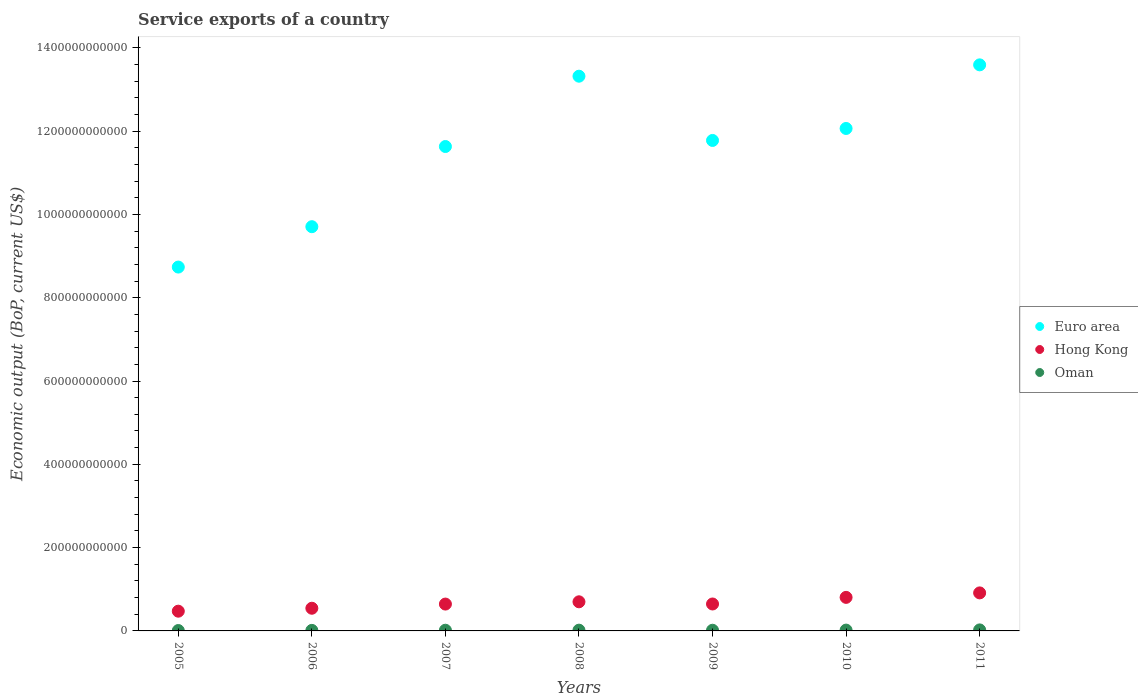How many different coloured dotlines are there?
Provide a short and direct response. 3. Is the number of dotlines equal to the number of legend labels?
Offer a very short reply. Yes. What is the service exports in Hong Kong in 2005?
Ensure brevity in your answer.  4.74e+1. Across all years, what is the maximum service exports in Hong Kong?
Provide a succinct answer. 9.13e+1. Across all years, what is the minimum service exports in Euro area?
Give a very brief answer. 8.74e+11. What is the total service exports in Hong Kong in the graph?
Give a very brief answer. 4.73e+11. What is the difference between the service exports in Oman in 2007 and that in 2010?
Ensure brevity in your answer.  -2.76e+08. What is the difference between the service exports in Hong Kong in 2009 and the service exports in Euro area in 2010?
Your response must be concise. -1.14e+12. What is the average service exports in Euro area per year?
Provide a short and direct response. 1.15e+12. In the year 2006, what is the difference between the service exports in Euro area and service exports in Hong Kong?
Provide a short and direct response. 9.16e+11. What is the ratio of the service exports in Oman in 2005 to that in 2010?
Offer a terse response. 0.48. Is the difference between the service exports in Euro area in 2005 and 2006 greater than the difference between the service exports in Hong Kong in 2005 and 2006?
Make the answer very short. No. What is the difference between the highest and the second highest service exports in Euro area?
Your answer should be compact. 2.72e+1. What is the difference between the highest and the lowest service exports in Oman?
Your answer should be very brief. 1.50e+09. Is it the case that in every year, the sum of the service exports in Hong Kong and service exports in Euro area  is greater than the service exports in Oman?
Offer a very short reply. Yes. Is the service exports in Hong Kong strictly greater than the service exports in Euro area over the years?
Keep it short and to the point. No. How many years are there in the graph?
Your response must be concise. 7. What is the difference between two consecutive major ticks on the Y-axis?
Make the answer very short. 2.00e+11. Does the graph contain any zero values?
Ensure brevity in your answer.  No. Does the graph contain grids?
Keep it short and to the point. No. Where does the legend appear in the graph?
Keep it short and to the point. Center right. How are the legend labels stacked?
Provide a succinct answer. Vertical. What is the title of the graph?
Offer a terse response. Service exports of a country. Does "Oman" appear as one of the legend labels in the graph?
Offer a very short reply. Yes. What is the label or title of the X-axis?
Offer a terse response. Years. What is the label or title of the Y-axis?
Make the answer very short. Economic output (BoP, current US$). What is the Economic output (BoP, current US$) of Euro area in 2005?
Your answer should be compact. 8.74e+11. What is the Economic output (BoP, current US$) of Hong Kong in 2005?
Your answer should be compact. 4.74e+1. What is the Economic output (BoP, current US$) in Oman in 2005?
Offer a terse response. 9.39e+08. What is the Economic output (BoP, current US$) of Euro area in 2006?
Offer a terse response. 9.70e+11. What is the Economic output (BoP, current US$) of Hong Kong in 2006?
Your answer should be very brief. 5.44e+1. What is the Economic output (BoP, current US$) in Oman in 2006?
Provide a succinct answer. 1.31e+09. What is the Economic output (BoP, current US$) in Euro area in 2007?
Offer a terse response. 1.16e+12. What is the Economic output (BoP, current US$) in Hong Kong in 2007?
Make the answer very short. 6.45e+1. What is the Economic output (BoP, current US$) in Oman in 2007?
Provide a succinct answer. 1.68e+09. What is the Economic output (BoP, current US$) of Euro area in 2008?
Offer a very short reply. 1.33e+12. What is the Economic output (BoP, current US$) in Hong Kong in 2008?
Offer a very short reply. 6.99e+1. What is the Economic output (BoP, current US$) of Oman in 2008?
Provide a short and direct response. 1.83e+09. What is the Economic output (BoP, current US$) in Euro area in 2009?
Make the answer very short. 1.18e+12. What is the Economic output (BoP, current US$) of Hong Kong in 2009?
Make the answer very short. 6.47e+1. What is the Economic output (BoP, current US$) in Oman in 2009?
Your answer should be compact. 1.62e+09. What is the Economic output (BoP, current US$) of Euro area in 2010?
Give a very brief answer. 1.21e+12. What is the Economic output (BoP, current US$) of Hong Kong in 2010?
Provide a short and direct response. 8.05e+1. What is the Economic output (BoP, current US$) in Oman in 2010?
Offer a terse response. 1.96e+09. What is the Economic output (BoP, current US$) in Euro area in 2011?
Your answer should be very brief. 1.36e+12. What is the Economic output (BoP, current US$) of Hong Kong in 2011?
Keep it short and to the point. 9.13e+1. What is the Economic output (BoP, current US$) of Oman in 2011?
Make the answer very short. 2.44e+09. Across all years, what is the maximum Economic output (BoP, current US$) of Euro area?
Your answer should be compact. 1.36e+12. Across all years, what is the maximum Economic output (BoP, current US$) of Hong Kong?
Provide a succinct answer. 9.13e+1. Across all years, what is the maximum Economic output (BoP, current US$) in Oman?
Provide a short and direct response. 2.44e+09. Across all years, what is the minimum Economic output (BoP, current US$) in Euro area?
Your answer should be compact. 8.74e+11. Across all years, what is the minimum Economic output (BoP, current US$) of Hong Kong?
Your answer should be compact. 4.74e+1. Across all years, what is the minimum Economic output (BoP, current US$) in Oman?
Make the answer very short. 9.39e+08. What is the total Economic output (BoP, current US$) of Euro area in the graph?
Give a very brief answer. 8.08e+12. What is the total Economic output (BoP, current US$) in Hong Kong in the graph?
Your answer should be very brief. 4.73e+11. What is the total Economic output (BoP, current US$) in Oman in the graph?
Provide a short and direct response. 1.18e+1. What is the difference between the Economic output (BoP, current US$) of Euro area in 2005 and that in 2006?
Offer a very short reply. -9.69e+1. What is the difference between the Economic output (BoP, current US$) of Hong Kong in 2005 and that in 2006?
Your response must be concise. -7.06e+09. What is the difference between the Economic output (BoP, current US$) of Oman in 2005 and that in 2006?
Ensure brevity in your answer.  -3.72e+08. What is the difference between the Economic output (BoP, current US$) of Euro area in 2005 and that in 2007?
Provide a short and direct response. -2.89e+11. What is the difference between the Economic output (BoP, current US$) of Hong Kong in 2005 and that in 2007?
Keep it short and to the point. -1.71e+1. What is the difference between the Economic output (BoP, current US$) in Oman in 2005 and that in 2007?
Make the answer very short. -7.44e+08. What is the difference between the Economic output (BoP, current US$) in Euro area in 2005 and that in 2008?
Your response must be concise. -4.58e+11. What is the difference between the Economic output (BoP, current US$) in Hong Kong in 2005 and that in 2008?
Keep it short and to the point. -2.25e+1. What is the difference between the Economic output (BoP, current US$) of Oman in 2005 and that in 2008?
Give a very brief answer. -8.87e+08. What is the difference between the Economic output (BoP, current US$) in Euro area in 2005 and that in 2009?
Give a very brief answer. -3.04e+11. What is the difference between the Economic output (BoP, current US$) in Hong Kong in 2005 and that in 2009?
Your answer should be very brief. -1.73e+1. What is the difference between the Economic output (BoP, current US$) in Oman in 2005 and that in 2009?
Your answer should be compact. -6.81e+08. What is the difference between the Economic output (BoP, current US$) in Euro area in 2005 and that in 2010?
Provide a succinct answer. -3.33e+11. What is the difference between the Economic output (BoP, current US$) in Hong Kong in 2005 and that in 2010?
Your response must be concise. -3.32e+1. What is the difference between the Economic output (BoP, current US$) in Oman in 2005 and that in 2010?
Make the answer very short. -1.02e+09. What is the difference between the Economic output (BoP, current US$) in Euro area in 2005 and that in 2011?
Provide a short and direct response. -4.85e+11. What is the difference between the Economic output (BoP, current US$) in Hong Kong in 2005 and that in 2011?
Give a very brief answer. -4.39e+1. What is the difference between the Economic output (BoP, current US$) of Oman in 2005 and that in 2011?
Provide a short and direct response. -1.50e+09. What is the difference between the Economic output (BoP, current US$) of Euro area in 2006 and that in 2007?
Your answer should be very brief. -1.92e+11. What is the difference between the Economic output (BoP, current US$) of Hong Kong in 2006 and that in 2007?
Offer a terse response. -1.00e+1. What is the difference between the Economic output (BoP, current US$) in Oman in 2006 and that in 2007?
Make the answer very short. -3.72e+08. What is the difference between the Economic output (BoP, current US$) of Euro area in 2006 and that in 2008?
Your response must be concise. -3.61e+11. What is the difference between the Economic output (BoP, current US$) in Hong Kong in 2006 and that in 2008?
Offer a terse response. -1.55e+1. What is the difference between the Economic output (BoP, current US$) in Oman in 2006 and that in 2008?
Your answer should be compact. -5.15e+08. What is the difference between the Economic output (BoP, current US$) of Euro area in 2006 and that in 2009?
Keep it short and to the point. -2.07e+11. What is the difference between the Economic output (BoP, current US$) of Hong Kong in 2006 and that in 2009?
Your answer should be very brief. -1.02e+1. What is the difference between the Economic output (BoP, current US$) of Oman in 2006 and that in 2009?
Make the answer very short. -3.09e+08. What is the difference between the Economic output (BoP, current US$) of Euro area in 2006 and that in 2010?
Offer a very short reply. -2.36e+11. What is the difference between the Economic output (BoP, current US$) in Hong Kong in 2006 and that in 2010?
Provide a short and direct response. -2.61e+1. What is the difference between the Economic output (BoP, current US$) in Oman in 2006 and that in 2010?
Ensure brevity in your answer.  -6.48e+08. What is the difference between the Economic output (BoP, current US$) of Euro area in 2006 and that in 2011?
Make the answer very short. -3.89e+11. What is the difference between the Economic output (BoP, current US$) in Hong Kong in 2006 and that in 2011?
Offer a very short reply. -3.69e+1. What is the difference between the Economic output (BoP, current US$) in Oman in 2006 and that in 2011?
Keep it short and to the point. -1.13e+09. What is the difference between the Economic output (BoP, current US$) in Euro area in 2007 and that in 2008?
Make the answer very short. -1.69e+11. What is the difference between the Economic output (BoP, current US$) of Hong Kong in 2007 and that in 2008?
Keep it short and to the point. -5.45e+09. What is the difference between the Economic output (BoP, current US$) of Oman in 2007 and that in 2008?
Give a very brief answer. -1.43e+08. What is the difference between the Economic output (BoP, current US$) of Euro area in 2007 and that in 2009?
Make the answer very short. -1.46e+1. What is the difference between the Economic output (BoP, current US$) of Hong Kong in 2007 and that in 2009?
Offer a very short reply. -2.16e+08. What is the difference between the Economic output (BoP, current US$) of Oman in 2007 and that in 2009?
Make the answer very short. 6.24e+07. What is the difference between the Economic output (BoP, current US$) of Euro area in 2007 and that in 2010?
Make the answer very short. -4.33e+1. What is the difference between the Economic output (BoP, current US$) of Hong Kong in 2007 and that in 2010?
Ensure brevity in your answer.  -1.61e+1. What is the difference between the Economic output (BoP, current US$) of Oman in 2007 and that in 2010?
Keep it short and to the point. -2.76e+08. What is the difference between the Economic output (BoP, current US$) of Euro area in 2007 and that in 2011?
Provide a succinct answer. -1.96e+11. What is the difference between the Economic output (BoP, current US$) in Hong Kong in 2007 and that in 2011?
Give a very brief answer. -2.68e+1. What is the difference between the Economic output (BoP, current US$) in Oman in 2007 and that in 2011?
Your answer should be very brief. -7.59e+08. What is the difference between the Economic output (BoP, current US$) of Euro area in 2008 and that in 2009?
Ensure brevity in your answer.  1.54e+11. What is the difference between the Economic output (BoP, current US$) in Hong Kong in 2008 and that in 2009?
Provide a short and direct response. 5.24e+09. What is the difference between the Economic output (BoP, current US$) of Oman in 2008 and that in 2009?
Provide a succinct answer. 2.05e+08. What is the difference between the Economic output (BoP, current US$) in Euro area in 2008 and that in 2010?
Your response must be concise. 1.25e+11. What is the difference between the Economic output (BoP, current US$) of Hong Kong in 2008 and that in 2010?
Give a very brief answer. -1.06e+1. What is the difference between the Economic output (BoP, current US$) in Oman in 2008 and that in 2010?
Provide a short and direct response. -1.33e+08. What is the difference between the Economic output (BoP, current US$) of Euro area in 2008 and that in 2011?
Your answer should be very brief. -2.72e+1. What is the difference between the Economic output (BoP, current US$) in Hong Kong in 2008 and that in 2011?
Provide a short and direct response. -2.14e+1. What is the difference between the Economic output (BoP, current US$) in Oman in 2008 and that in 2011?
Give a very brief answer. -6.16e+08. What is the difference between the Economic output (BoP, current US$) of Euro area in 2009 and that in 2010?
Make the answer very short. -2.88e+1. What is the difference between the Economic output (BoP, current US$) in Hong Kong in 2009 and that in 2010?
Give a very brief answer. -1.59e+1. What is the difference between the Economic output (BoP, current US$) in Oman in 2009 and that in 2010?
Ensure brevity in your answer.  -3.38e+08. What is the difference between the Economic output (BoP, current US$) in Euro area in 2009 and that in 2011?
Make the answer very short. -1.81e+11. What is the difference between the Economic output (BoP, current US$) in Hong Kong in 2009 and that in 2011?
Ensure brevity in your answer.  -2.66e+1. What is the difference between the Economic output (BoP, current US$) in Oman in 2009 and that in 2011?
Your response must be concise. -8.22e+08. What is the difference between the Economic output (BoP, current US$) of Euro area in 2010 and that in 2011?
Offer a very short reply. -1.53e+11. What is the difference between the Economic output (BoP, current US$) in Hong Kong in 2010 and that in 2011?
Your answer should be compact. -1.08e+1. What is the difference between the Economic output (BoP, current US$) in Oman in 2010 and that in 2011?
Make the answer very short. -4.84e+08. What is the difference between the Economic output (BoP, current US$) in Euro area in 2005 and the Economic output (BoP, current US$) in Hong Kong in 2006?
Give a very brief answer. 8.19e+11. What is the difference between the Economic output (BoP, current US$) in Euro area in 2005 and the Economic output (BoP, current US$) in Oman in 2006?
Provide a short and direct response. 8.72e+11. What is the difference between the Economic output (BoP, current US$) in Hong Kong in 2005 and the Economic output (BoP, current US$) in Oman in 2006?
Offer a very short reply. 4.61e+1. What is the difference between the Economic output (BoP, current US$) of Euro area in 2005 and the Economic output (BoP, current US$) of Hong Kong in 2007?
Provide a succinct answer. 8.09e+11. What is the difference between the Economic output (BoP, current US$) in Euro area in 2005 and the Economic output (BoP, current US$) in Oman in 2007?
Ensure brevity in your answer.  8.72e+11. What is the difference between the Economic output (BoP, current US$) in Hong Kong in 2005 and the Economic output (BoP, current US$) in Oman in 2007?
Your response must be concise. 4.57e+1. What is the difference between the Economic output (BoP, current US$) in Euro area in 2005 and the Economic output (BoP, current US$) in Hong Kong in 2008?
Your answer should be very brief. 8.04e+11. What is the difference between the Economic output (BoP, current US$) in Euro area in 2005 and the Economic output (BoP, current US$) in Oman in 2008?
Provide a succinct answer. 8.72e+11. What is the difference between the Economic output (BoP, current US$) of Hong Kong in 2005 and the Economic output (BoP, current US$) of Oman in 2008?
Provide a short and direct response. 4.56e+1. What is the difference between the Economic output (BoP, current US$) in Euro area in 2005 and the Economic output (BoP, current US$) in Hong Kong in 2009?
Provide a short and direct response. 8.09e+11. What is the difference between the Economic output (BoP, current US$) in Euro area in 2005 and the Economic output (BoP, current US$) in Oman in 2009?
Provide a short and direct response. 8.72e+11. What is the difference between the Economic output (BoP, current US$) in Hong Kong in 2005 and the Economic output (BoP, current US$) in Oman in 2009?
Offer a very short reply. 4.58e+1. What is the difference between the Economic output (BoP, current US$) of Euro area in 2005 and the Economic output (BoP, current US$) of Hong Kong in 2010?
Offer a terse response. 7.93e+11. What is the difference between the Economic output (BoP, current US$) of Euro area in 2005 and the Economic output (BoP, current US$) of Oman in 2010?
Provide a short and direct response. 8.72e+11. What is the difference between the Economic output (BoP, current US$) of Hong Kong in 2005 and the Economic output (BoP, current US$) of Oman in 2010?
Keep it short and to the point. 4.54e+1. What is the difference between the Economic output (BoP, current US$) of Euro area in 2005 and the Economic output (BoP, current US$) of Hong Kong in 2011?
Keep it short and to the point. 7.82e+11. What is the difference between the Economic output (BoP, current US$) of Euro area in 2005 and the Economic output (BoP, current US$) of Oman in 2011?
Your answer should be very brief. 8.71e+11. What is the difference between the Economic output (BoP, current US$) of Hong Kong in 2005 and the Economic output (BoP, current US$) of Oman in 2011?
Offer a terse response. 4.49e+1. What is the difference between the Economic output (BoP, current US$) in Euro area in 2006 and the Economic output (BoP, current US$) in Hong Kong in 2007?
Offer a very short reply. 9.06e+11. What is the difference between the Economic output (BoP, current US$) of Euro area in 2006 and the Economic output (BoP, current US$) of Oman in 2007?
Your response must be concise. 9.69e+11. What is the difference between the Economic output (BoP, current US$) in Hong Kong in 2006 and the Economic output (BoP, current US$) in Oman in 2007?
Keep it short and to the point. 5.28e+1. What is the difference between the Economic output (BoP, current US$) of Euro area in 2006 and the Economic output (BoP, current US$) of Hong Kong in 2008?
Your response must be concise. 9.01e+11. What is the difference between the Economic output (BoP, current US$) of Euro area in 2006 and the Economic output (BoP, current US$) of Oman in 2008?
Your answer should be compact. 9.69e+11. What is the difference between the Economic output (BoP, current US$) in Hong Kong in 2006 and the Economic output (BoP, current US$) in Oman in 2008?
Keep it short and to the point. 5.26e+1. What is the difference between the Economic output (BoP, current US$) of Euro area in 2006 and the Economic output (BoP, current US$) of Hong Kong in 2009?
Your answer should be very brief. 9.06e+11. What is the difference between the Economic output (BoP, current US$) of Euro area in 2006 and the Economic output (BoP, current US$) of Oman in 2009?
Offer a terse response. 9.69e+11. What is the difference between the Economic output (BoP, current US$) of Hong Kong in 2006 and the Economic output (BoP, current US$) of Oman in 2009?
Offer a very short reply. 5.28e+1. What is the difference between the Economic output (BoP, current US$) of Euro area in 2006 and the Economic output (BoP, current US$) of Hong Kong in 2010?
Offer a terse response. 8.90e+11. What is the difference between the Economic output (BoP, current US$) in Euro area in 2006 and the Economic output (BoP, current US$) in Oman in 2010?
Your response must be concise. 9.69e+11. What is the difference between the Economic output (BoP, current US$) in Hong Kong in 2006 and the Economic output (BoP, current US$) in Oman in 2010?
Provide a succinct answer. 5.25e+1. What is the difference between the Economic output (BoP, current US$) in Euro area in 2006 and the Economic output (BoP, current US$) in Hong Kong in 2011?
Provide a short and direct response. 8.79e+11. What is the difference between the Economic output (BoP, current US$) of Euro area in 2006 and the Economic output (BoP, current US$) of Oman in 2011?
Make the answer very short. 9.68e+11. What is the difference between the Economic output (BoP, current US$) in Hong Kong in 2006 and the Economic output (BoP, current US$) in Oman in 2011?
Provide a succinct answer. 5.20e+1. What is the difference between the Economic output (BoP, current US$) of Euro area in 2007 and the Economic output (BoP, current US$) of Hong Kong in 2008?
Your answer should be very brief. 1.09e+12. What is the difference between the Economic output (BoP, current US$) of Euro area in 2007 and the Economic output (BoP, current US$) of Oman in 2008?
Offer a terse response. 1.16e+12. What is the difference between the Economic output (BoP, current US$) of Hong Kong in 2007 and the Economic output (BoP, current US$) of Oman in 2008?
Your answer should be compact. 6.26e+1. What is the difference between the Economic output (BoP, current US$) in Euro area in 2007 and the Economic output (BoP, current US$) in Hong Kong in 2009?
Offer a very short reply. 1.10e+12. What is the difference between the Economic output (BoP, current US$) of Euro area in 2007 and the Economic output (BoP, current US$) of Oman in 2009?
Your answer should be compact. 1.16e+12. What is the difference between the Economic output (BoP, current US$) in Hong Kong in 2007 and the Economic output (BoP, current US$) in Oman in 2009?
Give a very brief answer. 6.28e+1. What is the difference between the Economic output (BoP, current US$) in Euro area in 2007 and the Economic output (BoP, current US$) in Hong Kong in 2010?
Your answer should be compact. 1.08e+12. What is the difference between the Economic output (BoP, current US$) in Euro area in 2007 and the Economic output (BoP, current US$) in Oman in 2010?
Offer a terse response. 1.16e+12. What is the difference between the Economic output (BoP, current US$) in Hong Kong in 2007 and the Economic output (BoP, current US$) in Oman in 2010?
Your response must be concise. 6.25e+1. What is the difference between the Economic output (BoP, current US$) in Euro area in 2007 and the Economic output (BoP, current US$) in Hong Kong in 2011?
Offer a very short reply. 1.07e+12. What is the difference between the Economic output (BoP, current US$) in Euro area in 2007 and the Economic output (BoP, current US$) in Oman in 2011?
Offer a terse response. 1.16e+12. What is the difference between the Economic output (BoP, current US$) in Hong Kong in 2007 and the Economic output (BoP, current US$) in Oman in 2011?
Make the answer very short. 6.20e+1. What is the difference between the Economic output (BoP, current US$) of Euro area in 2008 and the Economic output (BoP, current US$) of Hong Kong in 2009?
Give a very brief answer. 1.27e+12. What is the difference between the Economic output (BoP, current US$) in Euro area in 2008 and the Economic output (BoP, current US$) in Oman in 2009?
Your response must be concise. 1.33e+12. What is the difference between the Economic output (BoP, current US$) in Hong Kong in 2008 and the Economic output (BoP, current US$) in Oman in 2009?
Offer a very short reply. 6.83e+1. What is the difference between the Economic output (BoP, current US$) in Euro area in 2008 and the Economic output (BoP, current US$) in Hong Kong in 2010?
Make the answer very short. 1.25e+12. What is the difference between the Economic output (BoP, current US$) in Euro area in 2008 and the Economic output (BoP, current US$) in Oman in 2010?
Offer a terse response. 1.33e+12. What is the difference between the Economic output (BoP, current US$) in Hong Kong in 2008 and the Economic output (BoP, current US$) in Oman in 2010?
Make the answer very short. 6.79e+1. What is the difference between the Economic output (BoP, current US$) in Euro area in 2008 and the Economic output (BoP, current US$) in Hong Kong in 2011?
Make the answer very short. 1.24e+12. What is the difference between the Economic output (BoP, current US$) in Euro area in 2008 and the Economic output (BoP, current US$) in Oman in 2011?
Ensure brevity in your answer.  1.33e+12. What is the difference between the Economic output (BoP, current US$) of Hong Kong in 2008 and the Economic output (BoP, current US$) of Oman in 2011?
Offer a terse response. 6.75e+1. What is the difference between the Economic output (BoP, current US$) in Euro area in 2009 and the Economic output (BoP, current US$) in Hong Kong in 2010?
Make the answer very short. 1.10e+12. What is the difference between the Economic output (BoP, current US$) in Euro area in 2009 and the Economic output (BoP, current US$) in Oman in 2010?
Your response must be concise. 1.18e+12. What is the difference between the Economic output (BoP, current US$) in Hong Kong in 2009 and the Economic output (BoP, current US$) in Oman in 2010?
Provide a short and direct response. 6.27e+1. What is the difference between the Economic output (BoP, current US$) in Euro area in 2009 and the Economic output (BoP, current US$) in Hong Kong in 2011?
Make the answer very short. 1.09e+12. What is the difference between the Economic output (BoP, current US$) of Euro area in 2009 and the Economic output (BoP, current US$) of Oman in 2011?
Your answer should be compact. 1.18e+12. What is the difference between the Economic output (BoP, current US$) of Hong Kong in 2009 and the Economic output (BoP, current US$) of Oman in 2011?
Offer a terse response. 6.22e+1. What is the difference between the Economic output (BoP, current US$) in Euro area in 2010 and the Economic output (BoP, current US$) in Hong Kong in 2011?
Your response must be concise. 1.12e+12. What is the difference between the Economic output (BoP, current US$) of Euro area in 2010 and the Economic output (BoP, current US$) of Oman in 2011?
Provide a short and direct response. 1.20e+12. What is the difference between the Economic output (BoP, current US$) in Hong Kong in 2010 and the Economic output (BoP, current US$) in Oman in 2011?
Give a very brief answer. 7.81e+1. What is the average Economic output (BoP, current US$) in Euro area per year?
Ensure brevity in your answer.  1.15e+12. What is the average Economic output (BoP, current US$) of Hong Kong per year?
Your response must be concise. 6.75e+1. What is the average Economic output (BoP, current US$) in Oman per year?
Provide a short and direct response. 1.68e+09. In the year 2005, what is the difference between the Economic output (BoP, current US$) of Euro area and Economic output (BoP, current US$) of Hong Kong?
Provide a succinct answer. 8.26e+11. In the year 2005, what is the difference between the Economic output (BoP, current US$) of Euro area and Economic output (BoP, current US$) of Oman?
Your response must be concise. 8.73e+11. In the year 2005, what is the difference between the Economic output (BoP, current US$) in Hong Kong and Economic output (BoP, current US$) in Oman?
Make the answer very short. 4.64e+1. In the year 2006, what is the difference between the Economic output (BoP, current US$) of Euro area and Economic output (BoP, current US$) of Hong Kong?
Ensure brevity in your answer.  9.16e+11. In the year 2006, what is the difference between the Economic output (BoP, current US$) of Euro area and Economic output (BoP, current US$) of Oman?
Offer a terse response. 9.69e+11. In the year 2006, what is the difference between the Economic output (BoP, current US$) in Hong Kong and Economic output (BoP, current US$) in Oman?
Provide a succinct answer. 5.31e+1. In the year 2007, what is the difference between the Economic output (BoP, current US$) in Euro area and Economic output (BoP, current US$) in Hong Kong?
Give a very brief answer. 1.10e+12. In the year 2007, what is the difference between the Economic output (BoP, current US$) in Euro area and Economic output (BoP, current US$) in Oman?
Make the answer very short. 1.16e+12. In the year 2007, what is the difference between the Economic output (BoP, current US$) in Hong Kong and Economic output (BoP, current US$) in Oman?
Your answer should be very brief. 6.28e+1. In the year 2008, what is the difference between the Economic output (BoP, current US$) of Euro area and Economic output (BoP, current US$) of Hong Kong?
Your answer should be compact. 1.26e+12. In the year 2008, what is the difference between the Economic output (BoP, current US$) in Euro area and Economic output (BoP, current US$) in Oman?
Provide a succinct answer. 1.33e+12. In the year 2008, what is the difference between the Economic output (BoP, current US$) in Hong Kong and Economic output (BoP, current US$) in Oman?
Ensure brevity in your answer.  6.81e+1. In the year 2009, what is the difference between the Economic output (BoP, current US$) of Euro area and Economic output (BoP, current US$) of Hong Kong?
Provide a succinct answer. 1.11e+12. In the year 2009, what is the difference between the Economic output (BoP, current US$) in Euro area and Economic output (BoP, current US$) in Oman?
Your answer should be very brief. 1.18e+12. In the year 2009, what is the difference between the Economic output (BoP, current US$) of Hong Kong and Economic output (BoP, current US$) of Oman?
Ensure brevity in your answer.  6.30e+1. In the year 2010, what is the difference between the Economic output (BoP, current US$) of Euro area and Economic output (BoP, current US$) of Hong Kong?
Provide a succinct answer. 1.13e+12. In the year 2010, what is the difference between the Economic output (BoP, current US$) in Euro area and Economic output (BoP, current US$) in Oman?
Your answer should be compact. 1.20e+12. In the year 2010, what is the difference between the Economic output (BoP, current US$) of Hong Kong and Economic output (BoP, current US$) of Oman?
Ensure brevity in your answer.  7.86e+1. In the year 2011, what is the difference between the Economic output (BoP, current US$) in Euro area and Economic output (BoP, current US$) in Hong Kong?
Give a very brief answer. 1.27e+12. In the year 2011, what is the difference between the Economic output (BoP, current US$) of Euro area and Economic output (BoP, current US$) of Oman?
Your answer should be very brief. 1.36e+12. In the year 2011, what is the difference between the Economic output (BoP, current US$) of Hong Kong and Economic output (BoP, current US$) of Oman?
Ensure brevity in your answer.  8.89e+1. What is the ratio of the Economic output (BoP, current US$) in Euro area in 2005 to that in 2006?
Provide a short and direct response. 0.9. What is the ratio of the Economic output (BoP, current US$) of Hong Kong in 2005 to that in 2006?
Offer a very short reply. 0.87. What is the ratio of the Economic output (BoP, current US$) in Oman in 2005 to that in 2006?
Ensure brevity in your answer.  0.72. What is the ratio of the Economic output (BoP, current US$) in Euro area in 2005 to that in 2007?
Your response must be concise. 0.75. What is the ratio of the Economic output (BoP, current US$) in Hong Kong in 2005 to that in 2007?
Your answer should be very brief. 0.74. What is the ratio of the Economic output (BoP, current US$) in Oman in 2005 to that in 2007?
Provide a succinct answer. 0.56. What is the ratio of the Economic output (BoP, current US$) in Euro area in 2005 to that in 2008?
Ensure brevity in your answer.  0.66. What is the ratio of the Economic output (BoP, current US$) in Hong Kong in 2005 to that in 2008?
Offer a terse response. 0.68. What is the ratio of the Economic output (BoP, current US$) of Oman in 2005 to that in 2008?
Your response must be concise. 0.51. What is the ratio of the Economic output (BoP, current US$) in Euro area in 2005 to that in 2009?
Ensure brevity in your answer.  0.74. What is the ratio of the Economic output (BoP, current US$) of Hong Kong in 2005 to that in 2009?
Your response must be concise. 0.73. What is the ratio of the Economic output (BoP, current US$) in Oman in 2005 to that in 2009?
Your answer should be very brief. 0.58. What is the ratio of the Economic output (BoP, current US$) in Euro area in 2005 to that in 2010?
Your answer should be very brief. 0.72. What is the ratio of the Economic output (BoP, current US$) of Hong Kong in 2005 to that in 2010?
Ensure brevity in your answer.  0.59. What is the ratio of the Economic output (BoP, current US$) of Oman in 2005 to that in 2010?
Offer a terse response. 0.48. What is the ratio of the Economic output (BoP, current US$) in Euro area in 2005 to that in 2011?
Your answer should be very brief. 0.64. What is the ratio of the Economic output (BoP, current US$) of Hong Kong in 2005 to that in 2011?
Your answer should be compact. 0.52. What is the ratio of the Economic output (BoP, current US$) of Oman in 2005 to that in 2011?
Make the answer very short. 0.38. What is the ratio of the Economic output (BoP, current US$) of Euro area in 2006 to that in 2007?
Offer a terse response. 0.83. What is the ratio of the Economic output (BoP, current US$) in Hong Kong in 2006 to that in 2007?
Your answer should be very brief. 0.84. What is the ratio of the Economic output (BoP, current US$) in Oman in 2006 to that in 2007?
Make the answer very short. 0.78. What is the ratio of the Economic output (BoP, current US$) of Euro area in 2006 to that in 2008?
Offer a very short reply. 0.73. What is the ratio of the Economic output (BoP, current US$) of Hong Kong in 2006 to that in 2008?
Provide a short and direct response. 0.78. What is the ratio of the Economic output (BoP, current US$) of Oman in 2006 to that in 2008?
Offer a very short reply. 0.72. What is the ratio of the Economic output (BoP, current US$) of Euro area in 2006 to that in 2009?
Provide a short and direct response. 0.82. What is the ratio of the Economic output (BoP, current US$) in Hong Kong in 2006 to that in 2009?
Give a very brief answer. 0.84. What is the ratio of the Economic output (BoP, current US$) in Oman in 2006 to that in 2009?
Your answer should be very brief. 0.81. What is the ratio of the Economic output (BoP, current US$) in Euro area in 2006 to that in 2010?
Provide a succinct answer. 0.8. What is the ratio of the Economic output (BoP, current US$) of Hong Kong in 2006 to that in 2010?
Provide a succinct answer. 0.68. What is the ratio of the Economic output (BoP, current US$) in Oman in 2006 to that in 2010?
Your answer should be very brief. 0.67. What is the ratio of the Economic output (BoP, current US$) of Euro area in 2006 to that in 2011?
Offer a very short reply. 0.71. What is the ratio of the Economic output (BoP, current US$) in Hong Kong in 2006 to that in 2011?
Make the answer very short. 0.6. What is the ratio of the Economic output (BoP, current US$) of Oman in 2006 to that in 2011?
Make the answer very short. 0.54. What is the ratio of the Economic output (BoP, current US$) of Euro area in 2007 to that in 2008?
Provide a succinct answer. 0.87. What is the ratio of the Economic output (BoP, current US$) in Hong Kong in 2007 to that in 2008?
Your answer should be compact. 0.92. What is the ratio of the Economic output (BoP, current US$) in Oman in 2007 to that in 2008?
Offer a terse response. 0.92. What is the ratio of the Economic output (BoP, current US$) in Euro area in 2007 to that in 2009?
Your answer should be very brief. 0.99. What is the ratio of the Economic output (BoP, current US$) of Hong Kong in 2007 to that in 2009?
Your answer should be compact. 1. What is the ratio of the Economic output (BoP, current US$) in Euro area in 2007 to that in 2010?
Your response must be concise. 0.96. What is the ratio of the Economic output (BoP, current US$) in Hong Kong in 2007 to that in 2010?
Your answer should be compact. 0.8. What is the ratio of the Economic output (BoP, current US$) in Oman in 2007 to that in 2010?
Make the answer very short. 0.86. What is the ratio of the Economic output (BoP, current US$) in Euro area in 2007 to that in 2011?
Your answer should be very brief. 0.86. What is the ratio of the Economic output (BoP, current US$) in Hong Kong in 2007 to that in 2011?
Your answer should be compact. 0.71. What is the ratio of the Economic output (BoP, current US$) of Oman in 2007 to that in 2011?
Offer a very short reply. 0.69. What is the ratio of the Economic output (BoP, current US$) of Euro area in 2008 to that in 2009?
Ensure brevity in your answer.  1.13. What is the ratio of the Economic output (BoP, current US$) in Hong Kong in 2008 to that in 2009?
Ensure brevity in your answer.  1.08. What is the ratio of the Economic output (BoP, current US$) of Oman in 2008 to that in 2009?
Your response must be concise. 1.13. What is the ratio of the Economic output (BoP, current US$) of Euro area in 2008 to that in 2010?
Your response must be concise. 1.1. What is the ratio of the Economic output (BoP, current US$) of Hong Kong in 2008 to that in 2010?
Give a very brief answer. 0.87. What is the ratio of the Economic output (BoP, current US$) in Oman in 2008 to that in 2010?
Give a very brief answer. 0.93. What is the ratio of the Economic output (BoP, current US$) in Hong Kong in 2008 to that in 2011?
Your answer should be compact. 0.77. What is the ratio of the Economic output (BoP, current US$) of Oman in 2008 to that in 2011?
Your answer should be very brief. 0.75. What is the ratio of the Economic output (BoP, current US$) of Euro area in 2009 to that in 2010?
Give a very brief answer. 0.98. What is the ratio of the Economic output (BoP, current US$) in Hong Kong in 2009 to that in 2010?
Offer a very short reply. 0.8. What is the ratio of the Economic output (BoP, current US$) of Oman in 2009 to that in 2010?
Your response must be concise. 0.83. What is the ratio of the Economic output (BoP, current US$) in Euro area in 2009 to that in 2011?
Give a very brief answer. 0.87. What is the ratio of the Economic output (BoP, current US$) of Hong Kong in 2009 to that in 2011?
Offer a terse response. 0.71. What is the ratio of the Economic output (BoP, current US$) in Oman in 2009 to that in 2011?
Provide a succinct answer. 0.66. What is the ratio of the Economic output (BoP, current US$) of Euro area in 2010 to that in 2011?
Ensure brevity in your answer.  0.89. What is the ratio of the Economic output (BoP, current US$) of Hong Kong in 2010 to that in 2011?
Provide a short and direct response. 0.88. What is the ratio of the Economic output (BoP, current US$) of Oman in 2010 to that in 2011?
Offer a very short reply. 0.8. What is the difference between the highest and the second highest Economic output (BoP, current US$) in Euro area?
Your answer should be compact. 2.72e+1. What is the difference between the highest and the second highest Economic output (BoP, current US$) in Hong Kong?
Ensure brevity in your answer.  1.08e+1. What is the difference between the highest and the second highest Economic output (BoP, current US$) in Oman?
Offer a very short reply. 4.84e+08. What is the difference between the highest and the lowest Economic output (BoP, current US$) in Euro area?
Provide a succinct answer. 4.85e+11. What is the difference between the highest and the lowest Economic output (BoP, current US$) in Hong Kong?
Make the answer very short. 4.39e+1. What is the difference between the highest and the lowest Economic output (BoP, current US$) of Oman?
Give a very brief answer. 1.50e+09. 